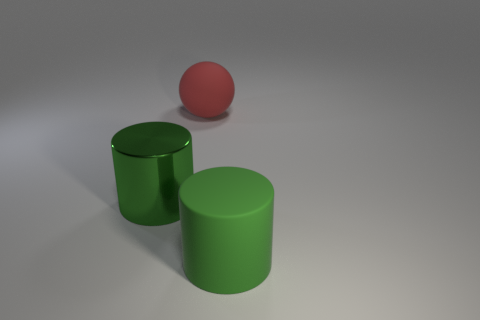Are there any green metallic things behind the big green cylinder that is right of the shiny object?
Keep it short and to the point. Yes. There is a big red rubber object; is its shape the same as the big thing that is on the left side of the sphere?
Offer a terse response. No. What size is the thing that is both in front of the big red sphere and on the right side of the large metal object?
Give a very brief answer. Large. There is a matte cylinder that is the same color as the large metal cylinder; what is its size?
Offer a terse response. Large. What material is the large green object in front of the green cylinder on the left side of the large green matte cylinder made of?
Provide a short and direct response. Rubber. What number of other big cylinders are the same color as the big shiny cylinder?
Give a very brief answer. 1. There is a green thing that is the same material as the sphere; what is its size?
Provide a short and direct response. Large. There is a object behind the big metallic cylinder; what is its shape?
Give a very brief answer. Sphere. The other thing that is the same shape as the big green shiny thing is what size?
Provide a short and direct response. Large. What number of objects are in front of the big green metal cylinder that is left of the rubber object behind the big rubber cylinder?
Give a very brief answer. 1. 